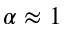Convert formula to latex. <formula><loc_0><loc_0><loc_500><loc_500>\alpha \approx 1</formula> 